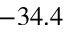Convert formula to latex. <formula><loc_0><loc_0><loc_500><loc_500>- 3 4 . 4</formula> 